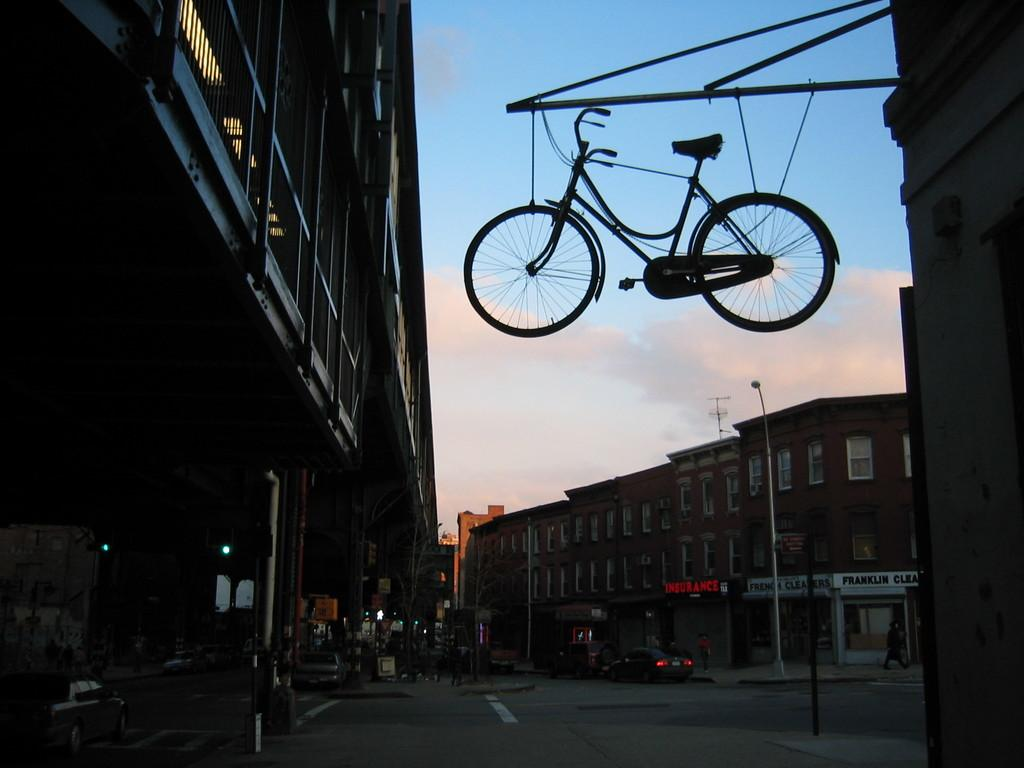What type of structures can be seen in the image? There are buildings in the image. What objects are present in the image that might be used for support or signage? There are poles in the image. What can be seen illuminating the scene in the image? There are lights in the image. What mode of transportation is visible in the image? There are vehicles in the image. Can you describe the group of people in the image? There is a group of people in the image. What unusual object can be seen in the image, seemingly defying gravity? There is a bicycle in the air, tied with cables to a metal rod. What type of legal advice is the lawyer giving to the father in the image? There is no lawyer or father present in the image, so it is not possible to answer that question. What card game is being played by the group of people in the image? There is no card game being played in the image; the group of people is not engaged in any activity. 